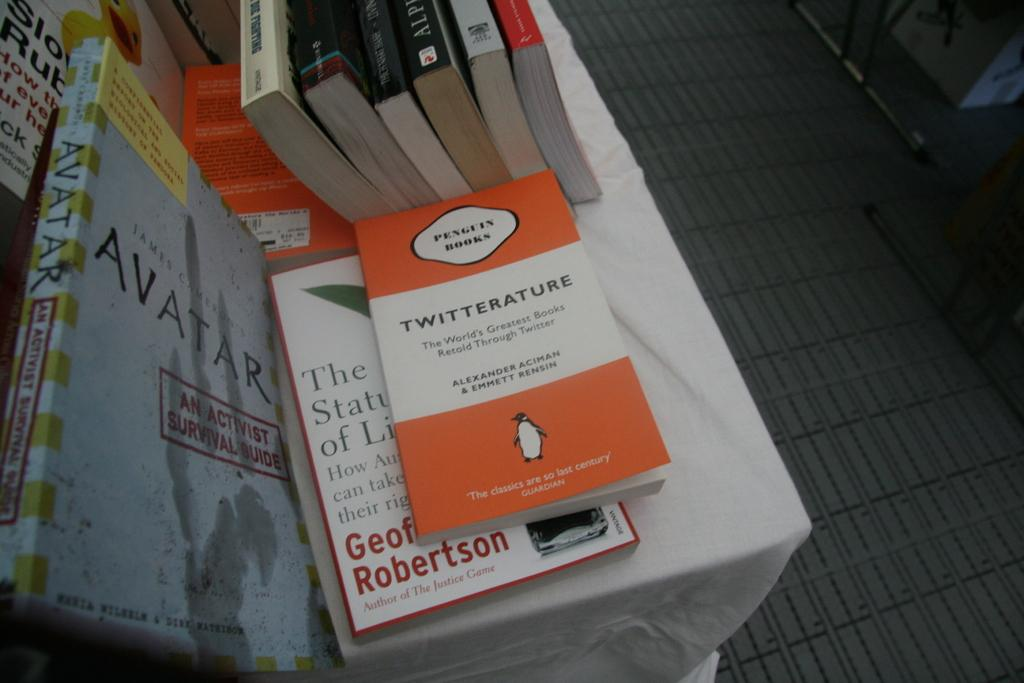What color is the table in the image? The table in the image is white. Where is the table located in relation to the wall? The table is near a wall. What items can be seen on the table? There are books on the table. What type of flooring is visible beside the table? There is a path with gray tiles beside the table. Is the farmer in the image pouring hot liquid on the table? There is no farmer or hot liquid present in the image. 